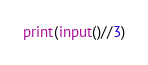<code> <loc_0><loc_0><loc_500><loc_500><_Python_>print(input()//3)</code> 